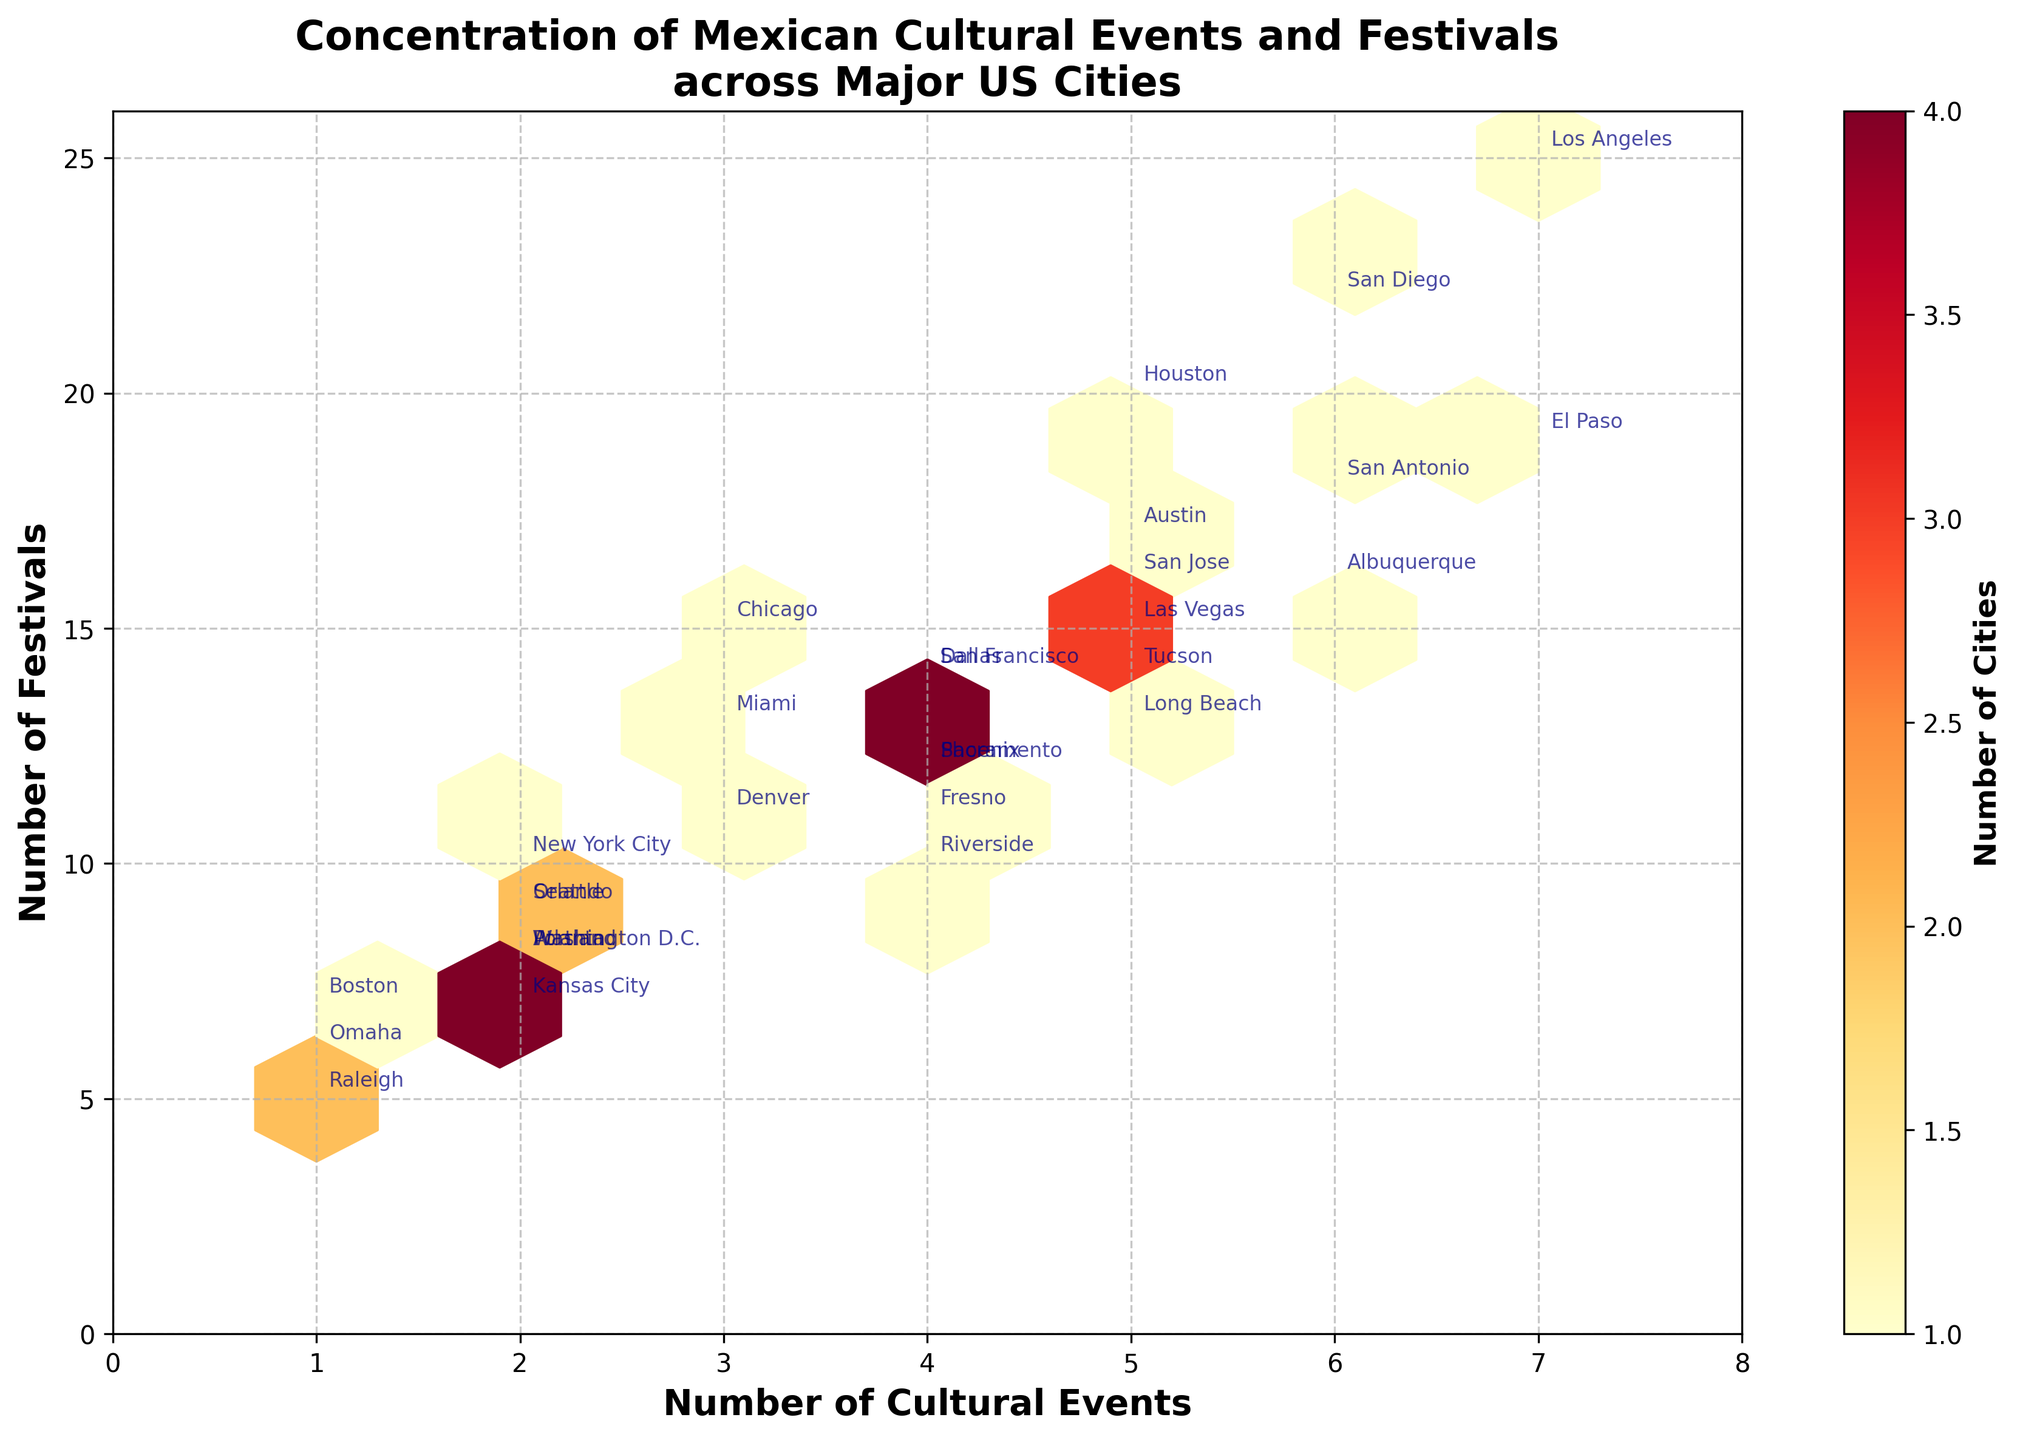What is the title of the hexbin plot? The title of the hexbin plot is located at the top of the figure, displayed in bold text.
Answer: Concentration of Mexican Cultural Events and Festivals across Major US Cities Which city has the highest number of cultural events? By looking at the annotations on the hexbin plot, find the city associated with the maximum value on the x-axis (number of cultural events).
Answer: Los Angeles and El Paso Which cities have both cultural events and festivals in the range from 5 to 15? Examine the range of values on both axes between 5 and 15 and look at the annotations to find the city names in this range.
Answer: Houston, San Antonio, San Diego, San Jose, Dallas, San Francisco, Austin, Las Vegas, Albuquerque, Tucson, Long Beach How many cities have exactly 4 cultural events? Count the number of hexagons along the vertical line that intersects the value 4 on the x-axis and check the annotations on those hexagons.
Answer: 5 What is the color of the hexagons representing the highest concentration of cities? Look at the color bar on the right side of the plot and identify which color corresponds to the highest number in the range.
Answer: Dark red What is the median number of festivals for cities with 5 cultural events? Identify the hexagons where the x-axis (number of cultural events) is 5, note the y-values (number of festivals), and calculate the median of those values. The cities include Houston, San Jose, Austin, Las Vegas, Tucson, Long Beach. The festival counts are 20, 16, 17, 15, 14, 13. The median is the middle value if arranged in order.
Answer: 16 Which city with 3 festivals is the closest to having the maximum number of cultural events? Look at the y-axis for the value 3 (number of festivals), find the cities along this line, and identify the one with the highest x-value (number of cultural events).
Answer: Chicago Are there any cities that have the same number of cultural events and festivals? Look for any hexagons along the line where the x and y values are equal (y = x) and identify the corresponding city if any.
Answer: None Which cities have the least number of festivals and how many cultural events do they have? Find the annotations along the line where the y-axis value is minimum (number of festivals) and look at their corresponding x-axis value (number of cultural events).
Answer: Raleigh and Omaha, both have 1 cultural event Considering the plot's color scheme, what does a lighter hexagon represent? Check the color bar legend: lighter colors represent fewer numbers. Refer to the legend on the right side.
Answer: Fewer cities 